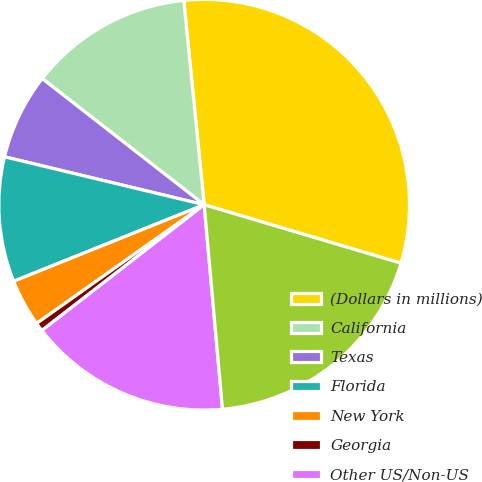Convert chart. <chart><loc_0><loc_0><loc_500><loc_500><pie_chart><fcel>(Dollars in millions)<fcel>California<fcel>Texas<fcel>Florida<fcel>New York<fcel>Georgia<fcel>Other US/Non-US<fcel>Total direct/indirect loan<nl><fcel>31.18%<fcel>12.88%<fcel>6.78%<fcel>9.83%<fcel>3.73%<fcel>0.68%<fcel>15.93%<fcel>18.98%<nl></chart> 